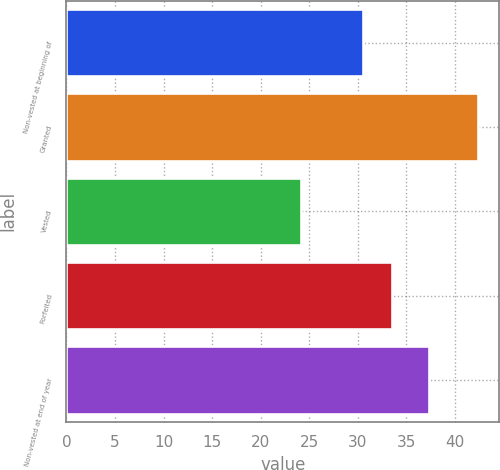Convert chart to OTSL. <chart><loc_0><loc_0><loc_500><loc_500><bar_chart><fcel>Non-vested at beginning of<fcel>Granted<fcel>Vested<fcel>Forfeited<fcel>Non-vested at end of year<nl><fcel>30.55<fcel>42.4<fcel>24.15<fcel>33.47<fcel>37.35<nl></chart> 